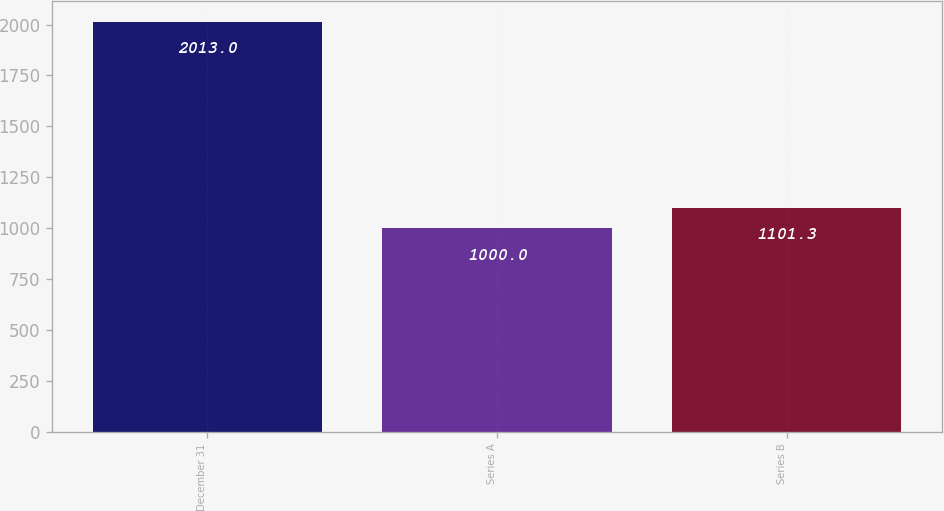Convert chart. <chart><loc_0><loc_0><loc_500><loc_500><bar_chart><fcel>December 31<fcel>Series A<fcel>Series B<nl><fcel>2013<fcel>1000<fcel>1101.3<nl></chart> 